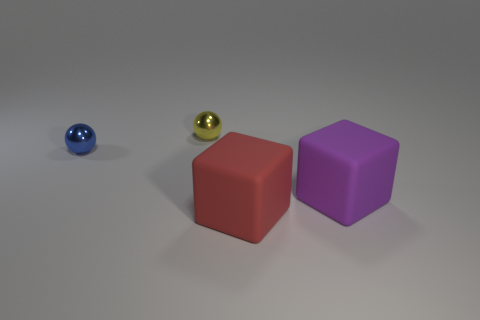Add 3 small metallic objects. How many objects exist? 7 Add 1 big purple rubber cubes. How many big purple rubber cubes exist? 2 Subtract 0 gray cubes. How many objects are left? 4 Subtract all large cubes. Subtract all yellow spheres. How many objects are left? 1 Add 3 yellow objects. How many yellow objects are left? 4 